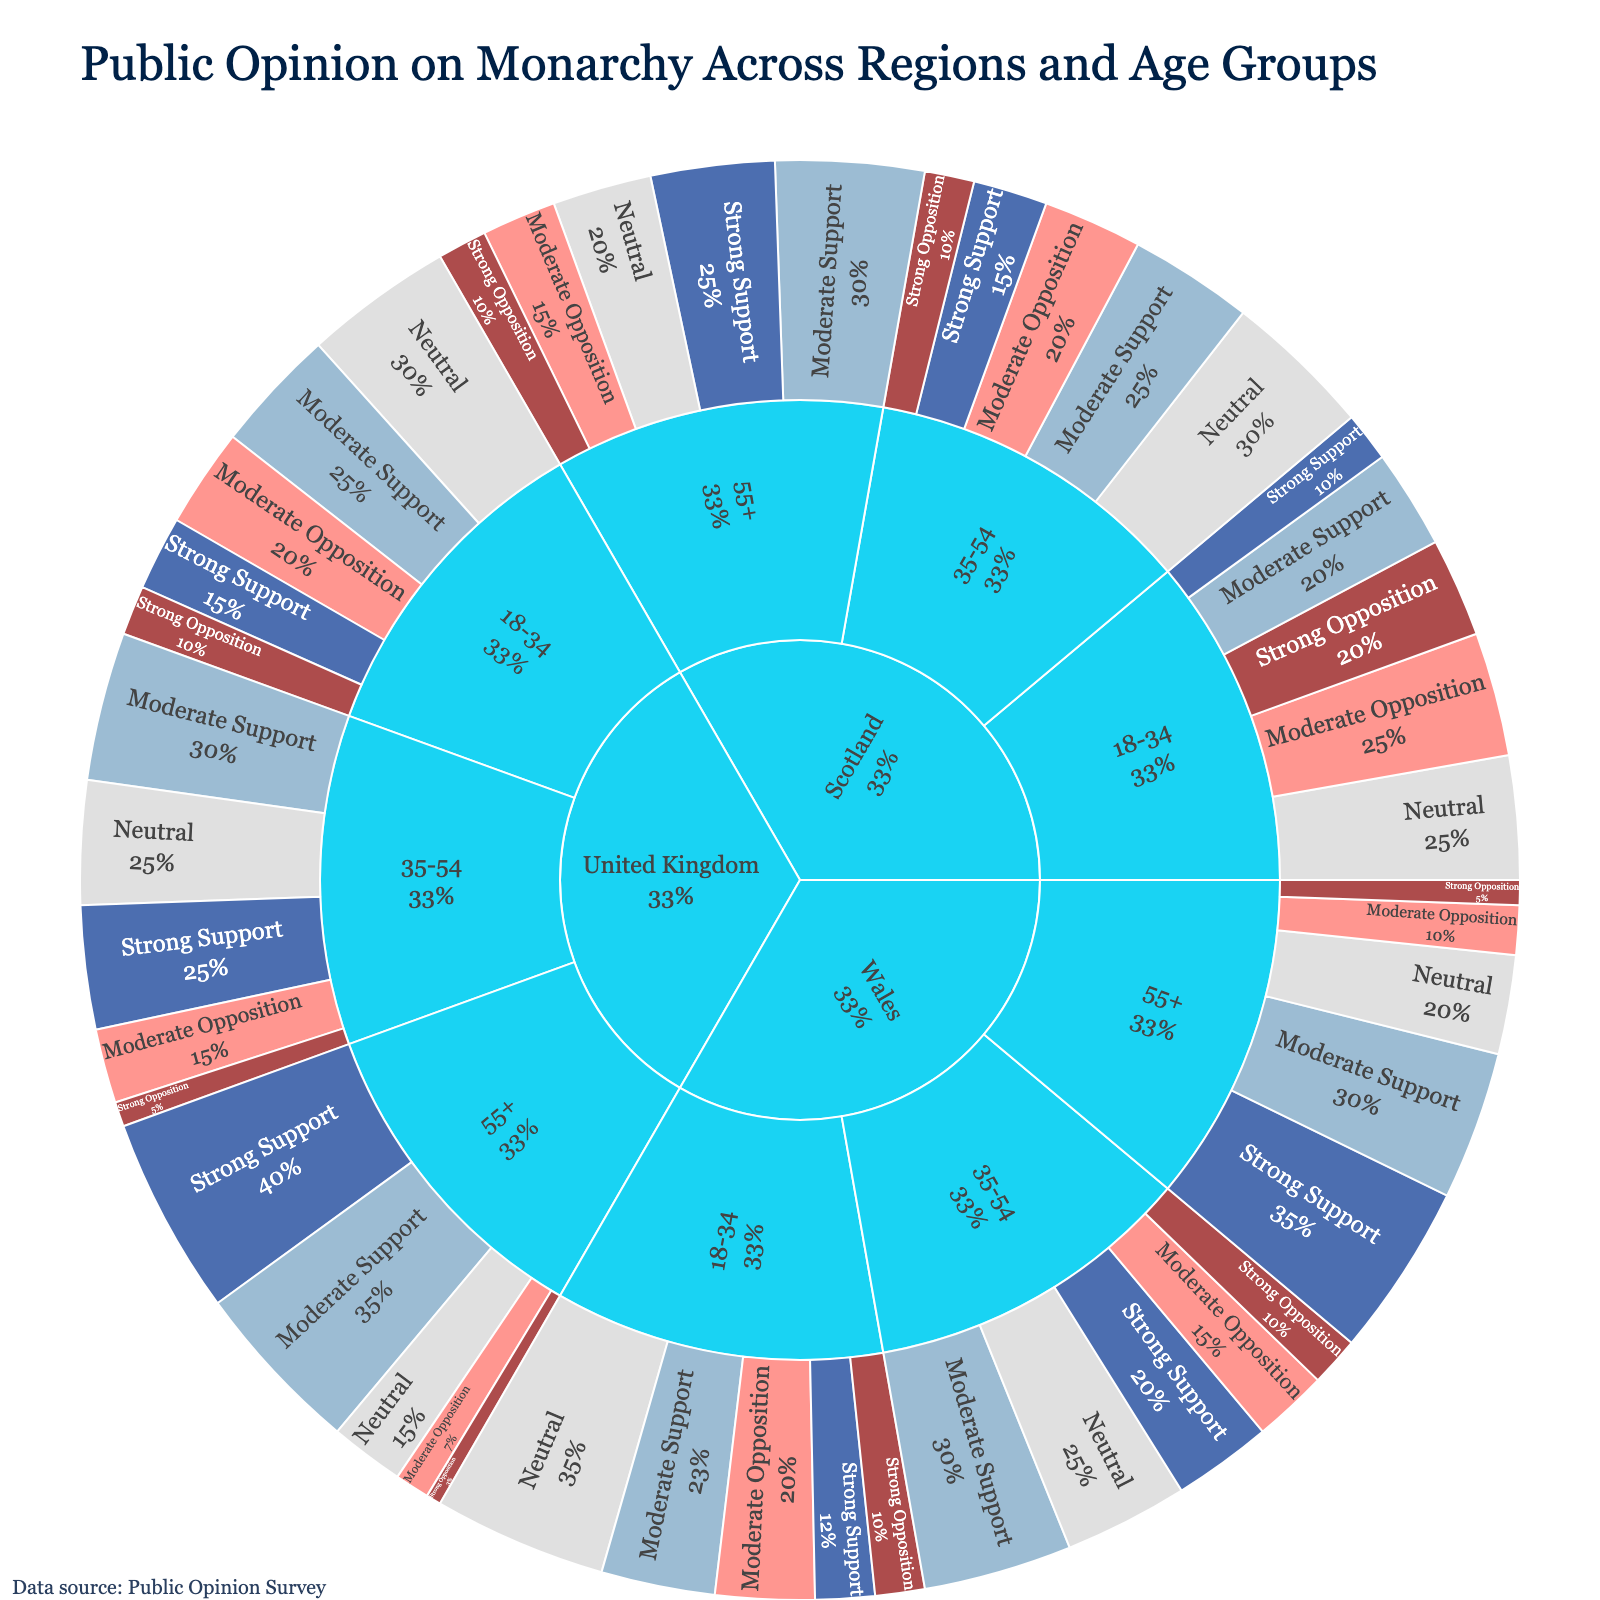What is the title of the figure? The title is prominently displayed at the top of the figure. It reads "Public Opinion on Monarchy Across Regions and Age Groups".
Answer: Public Opinion on Monarchy Across Regions and Age Groups What region has the highest percentage of strong support for the monarchy among people aged 55+? To find this, navigate to the United Kingdom > 55+ > Strong Support section in the sunburst plot. The United Kingdom has the highest percentage with 40%.
Answer: United Kingdom Which region has the most balanced opinion (closest percentages) among the 18-34 age group? Look at the segments corresponding to each region under the 18-34 age group and compare the percentage differences. Scotland shows more balanced opinions with relatively closer percentages across the support levels.
Answer: Scotland Across all age groups, which region shows the highest percentage for strong opposition to the monarchy? Within each region, navigate to the sections labeled Strong Opposition for each age group. Specifically, for Scotland and the age group 18-34, the percentage is highest at 20%.
Answer: Scotland What is the total percentage of moderate support for the monarchy in Wales? Sum up the moderate support percentages across all age groups in Wales: 23% (18-34) + 30% (35-54) + 30% (55+). Therefore, the total is 83%.
Answer: 83% Compare the combined percentages of neutral opinions between United Kingdom and Scotland for people aged 18-34. Which one is higher? Sum up the neutral percentages for both regions within the 18-34 age group: United Kingdom is 30%, and Scotland is 25%. Therefore, United Kingdom has a higher percentage.
Answer: United Kingdom In the age group 35-54, which region has a higher percentage of moderate opposition to the monarchy, United Kingdom or Wales? Compare the section labeled moderate opposition in the 35-54 age group for both regions. United Kingdom has 15% whereas Wales has 15%. They are equal.
Answer: They are equal What percentage of older adults (55+) in Scotland show moderate support for the monarchy? Navigate to the Scotland > 55+ > Moderate Support section. It shows 30%.
Answer: 30% Which age group in the United Kingdom shows the highest percentage of strong opposition to the monarchy? Check the segments labeled strong opposition within the United Kingdom for each age group: 18-34 is 10%, 35-54 is 5%, and 55+ is 3%. Thus, 18-34 age group shows the highest percentage.
Answer: 18-34 What is the difference in strong support for the monarchy between the 35-54 and 55+ age groups in Wales? Subtract the strong support percentage for the 35-54 age group from that of the 55+ age group in Wales: 35% (55+) - 20% (35-54) = 15%.
Answer: 15% 